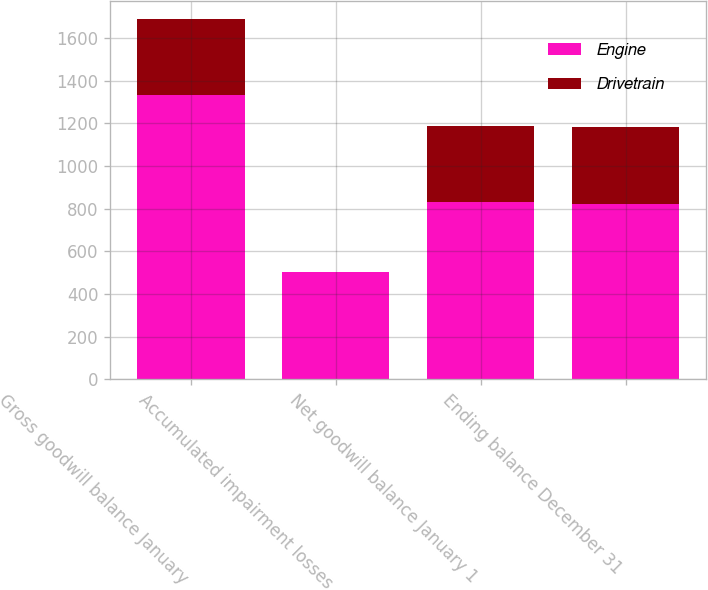<chart> <loc_0><loc_0><loc_500><loc_500><stacked_bar_chart><ecel><fcel>Gross goodwill balance January<fcel>Accumulated impairment losses<fcel>Net goodwill balance January 1<fcel>Ending balance December 31<nl><fcel>Engine<fcel>1334.7<fcel>501.8<fcel>832.9<fcel>822.3<nl><fcel>Drivetrain<fcel>353.5<fcel>0.2<fcel>353.3<fcel>359.1<nl></chart> 